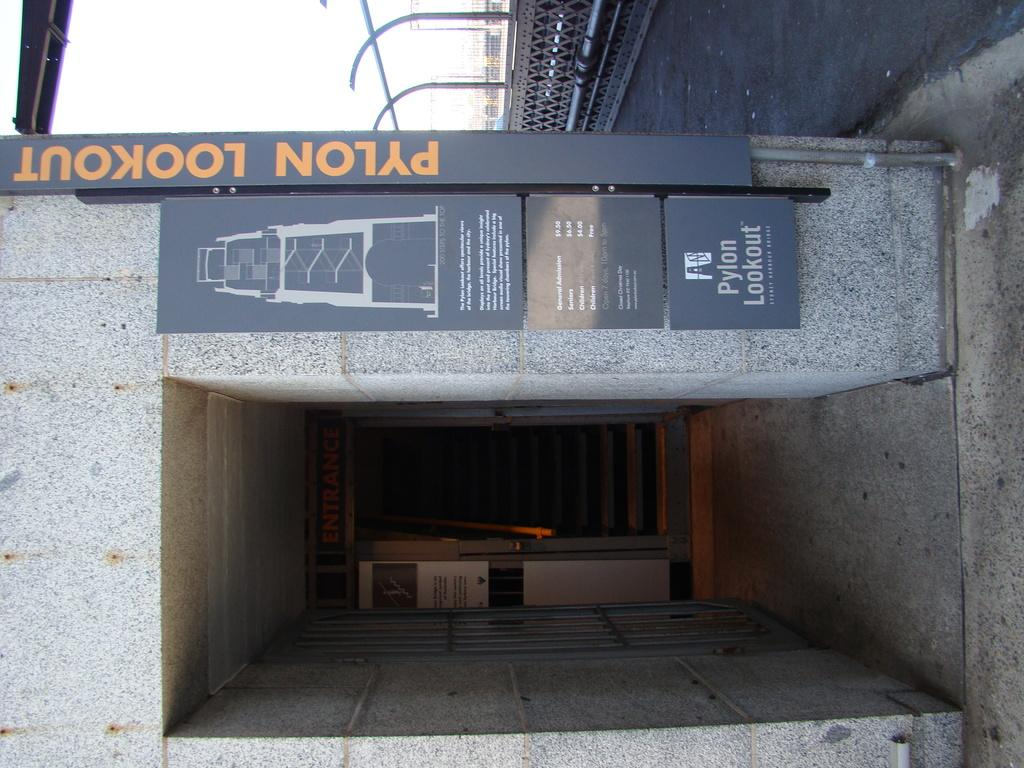What type of transportation equipment is in the image? There is an elevator in the image. What is written or displayed on a board in the image? There is a board with text in the image. What can be seen to the right side of the image? There is a road visible to the right side of the image. What type of structural elements are present in the image? There are rods present in the image. What is visible at the top of the image? The sky is visible at the top of the image. Reasoning: Let's think step by step by step in order to produce the conversation. We start by identifying the main subjects and objects in the image based on the provided facts. We then formulate questions that focus on the location and characteristics of these subjects and objects, ensuring that each question can be answered definitively with the information given. We avoid yes/no questions and ensure that the language is simple and clear. Absurd Question/Answer: What type of creature is holding the plate in the image? There is no creature or plate present in the image. What type of cable is connected to the rods in the image? There is no cable mentioned or visible in the image; only rods are present. What type of creature is holding the plate in the image? There is no creature or plate present in the image. What type of cable is connected to the rods in the image? There is no cable mentioned or visible in the image; only rods are present. 